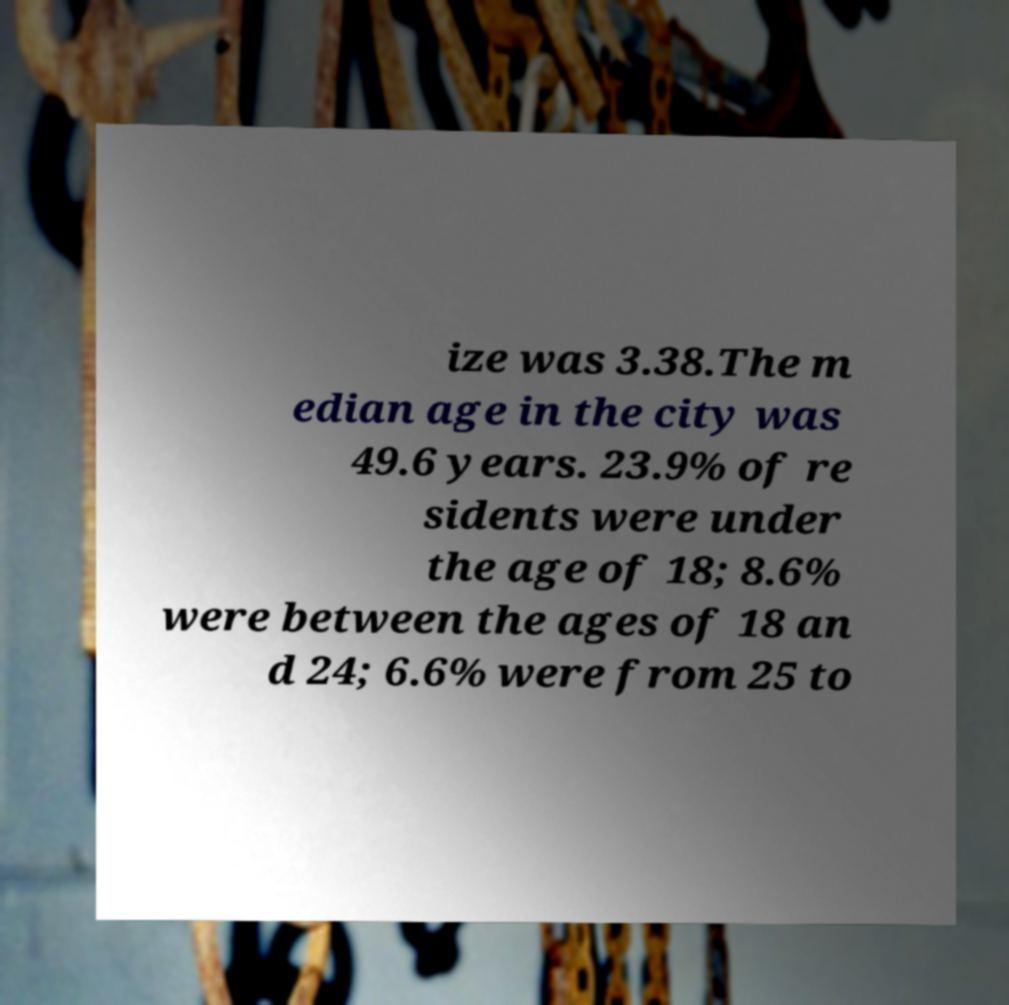Please read and relay the text visible in this image. What does it say? ize was 3.38.The m edian age in the city was 49.6 years. 23.9% of re sidents were under the age of 18; 8.6% were between the ages of 18 an d 24; 6.6% were from 25 to 